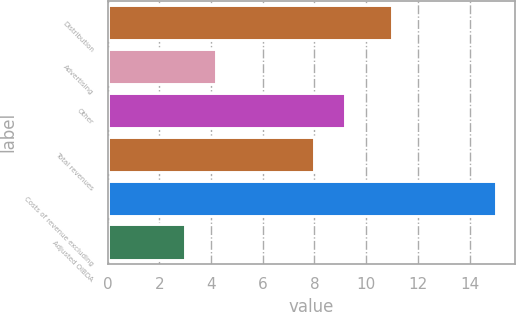Convert chart. <chart><loc_0><loc_0><loc_500><loc_500><bar_chart><fcel>Distribution<fcel>Advertising<fcel>Other<fcel>Total revenues<fcel>Costs of revenue excluding<fcel>Adjusted OIBDA<nl><fcel>11<fcel>4.2<fcel>9.2<fcel>8<fcel>15<fcel>3<nl></chart> 